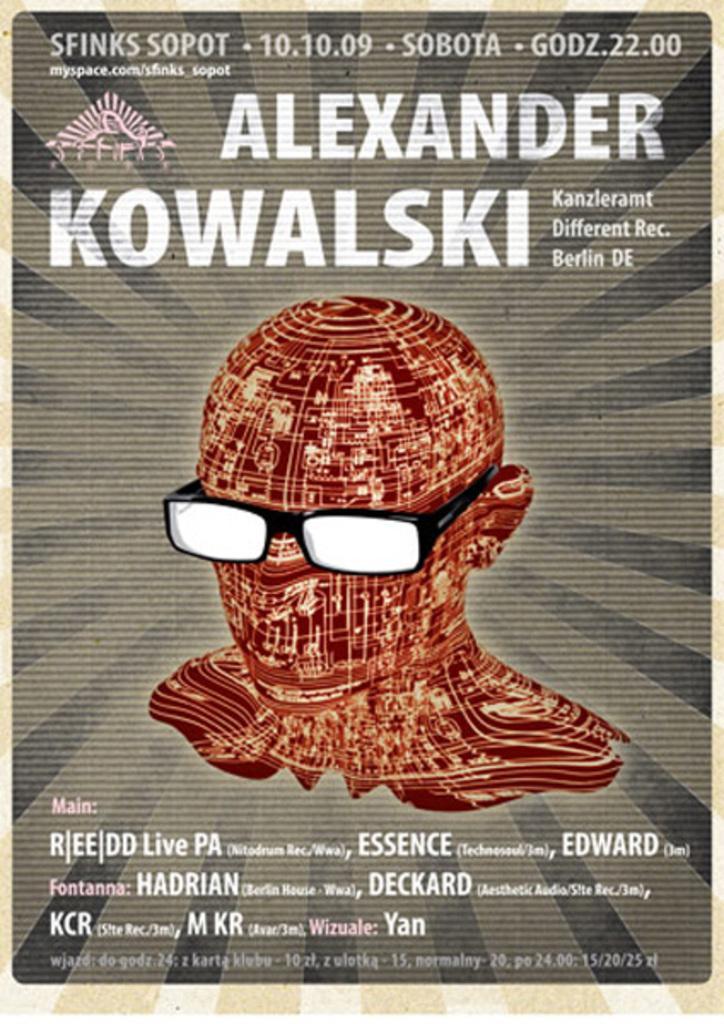Can you describe this image briefly? In this image we can see a poster. On the poster we can see some text and an animation of a person in the image. 